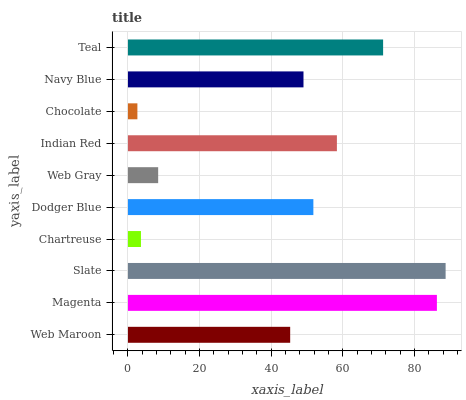Is Chocolate the minimum?
Answer yes or no. Yes. Is Slate the maximum?
Answer yes or no. Yes. Is Magenta the minimum?
Answer yes or no. No. Is Magenta the maximum?
Answer yes or no. No. Is Magenta greater than Web Maroon?
Answer yes or no. Yes. Is Web Maroon less than Magenta?
Answer yes or no. Yes. Is Web Maroon greater than Magenta?
Answer yes or no. No. Is Magenta less than Web Maroon?
Answer yes or no. No. Is Dodger Blue the high median?
Answer yes or no. Yes. Is Navy Blue the low median?
Answer yes or no. Yes. Is Web Gray the high median?
Answer yes or no. No. Is Magenta the low median?
Answer yes or no. No. 